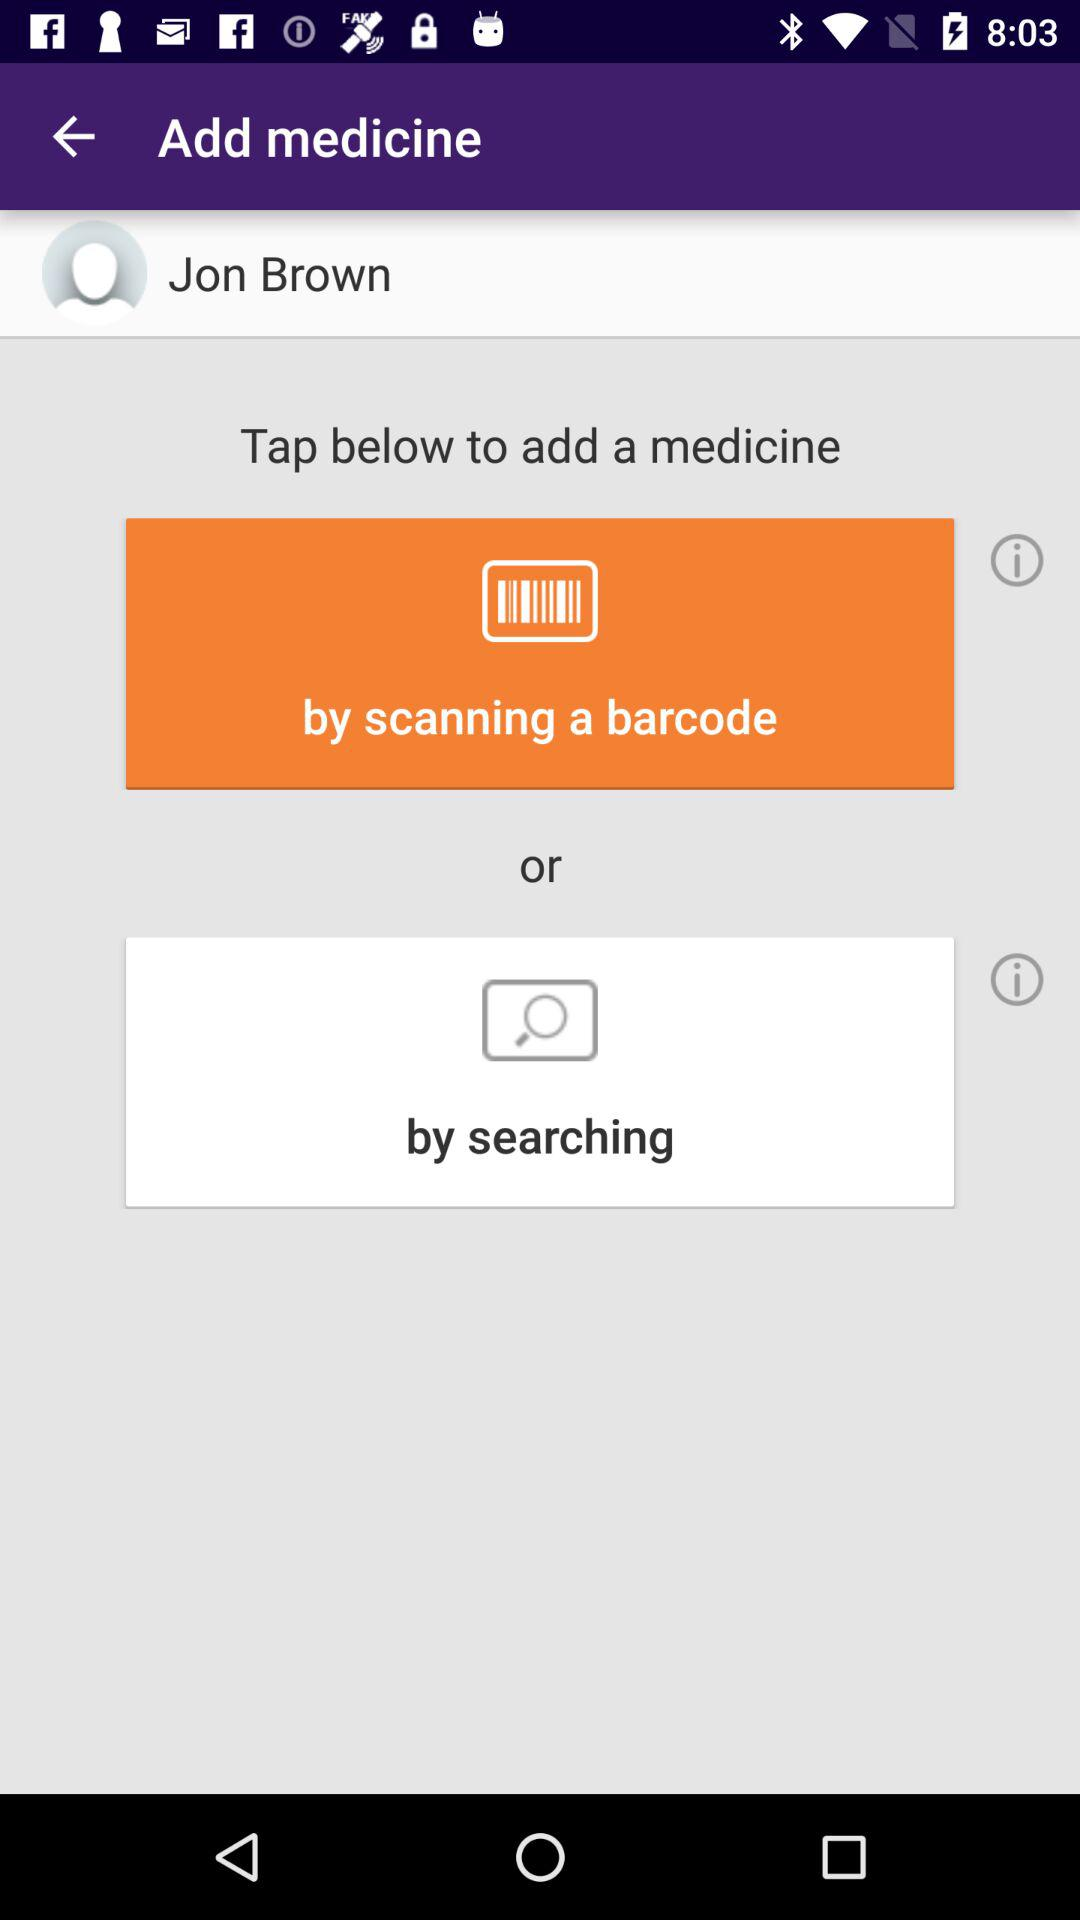What are the options for adding a medicine? The options are "by scanning a barcode" and "by searching". 